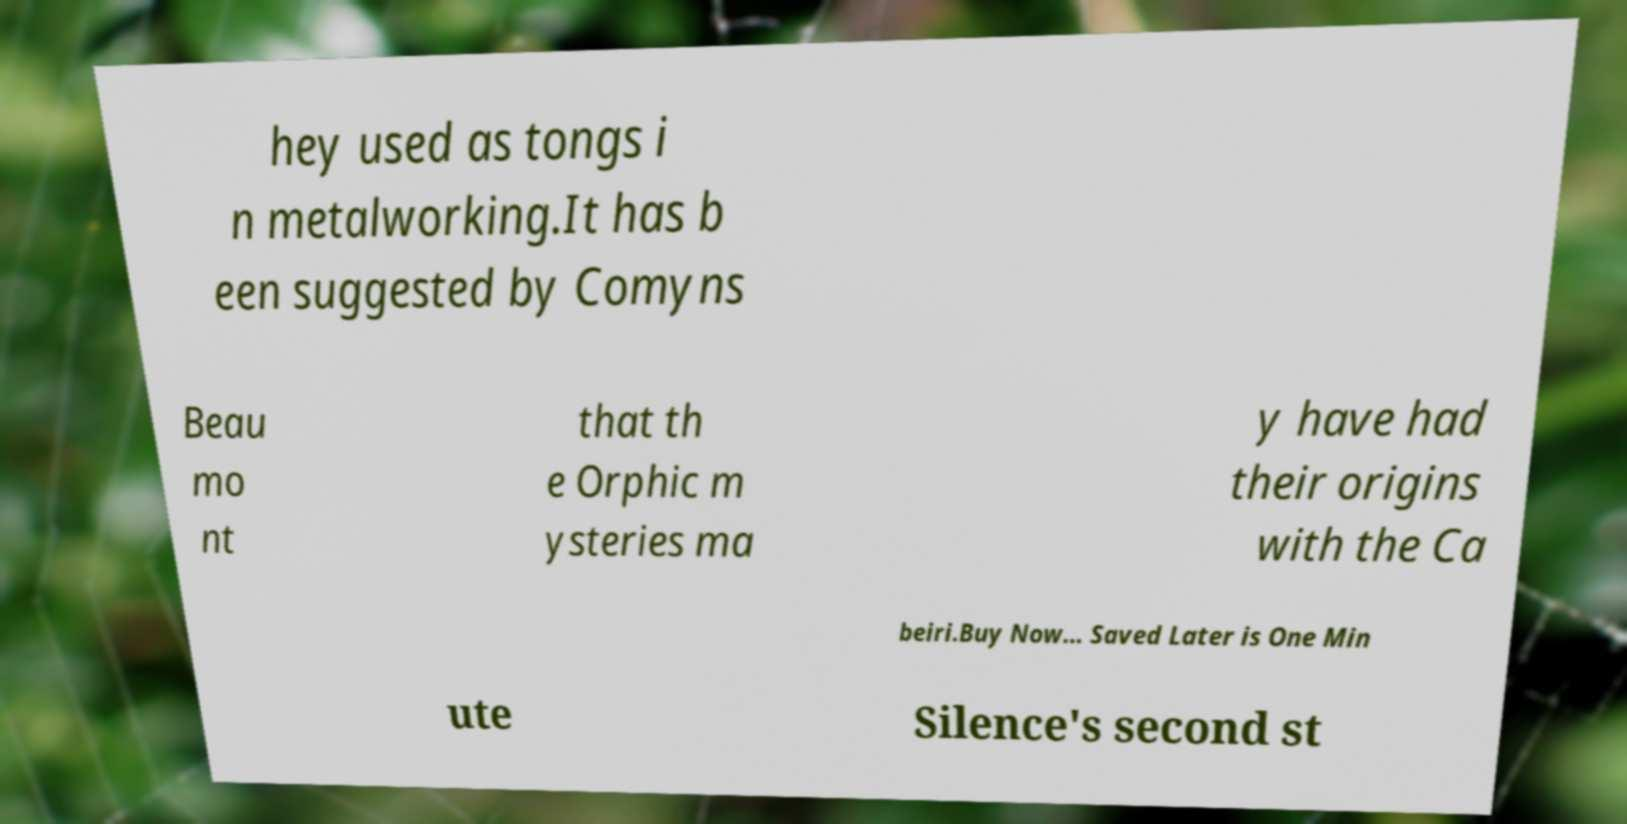I need the written content from this picture converted into text. Can you do that? hey used as tongs i n metalworking.It has b een suggested by Comyns Beau mo nt that th e Orphic m ysteries ma y have had their origins with the Ca beiri.Buy Now... Saved Later is One Min ute Silence's second st 